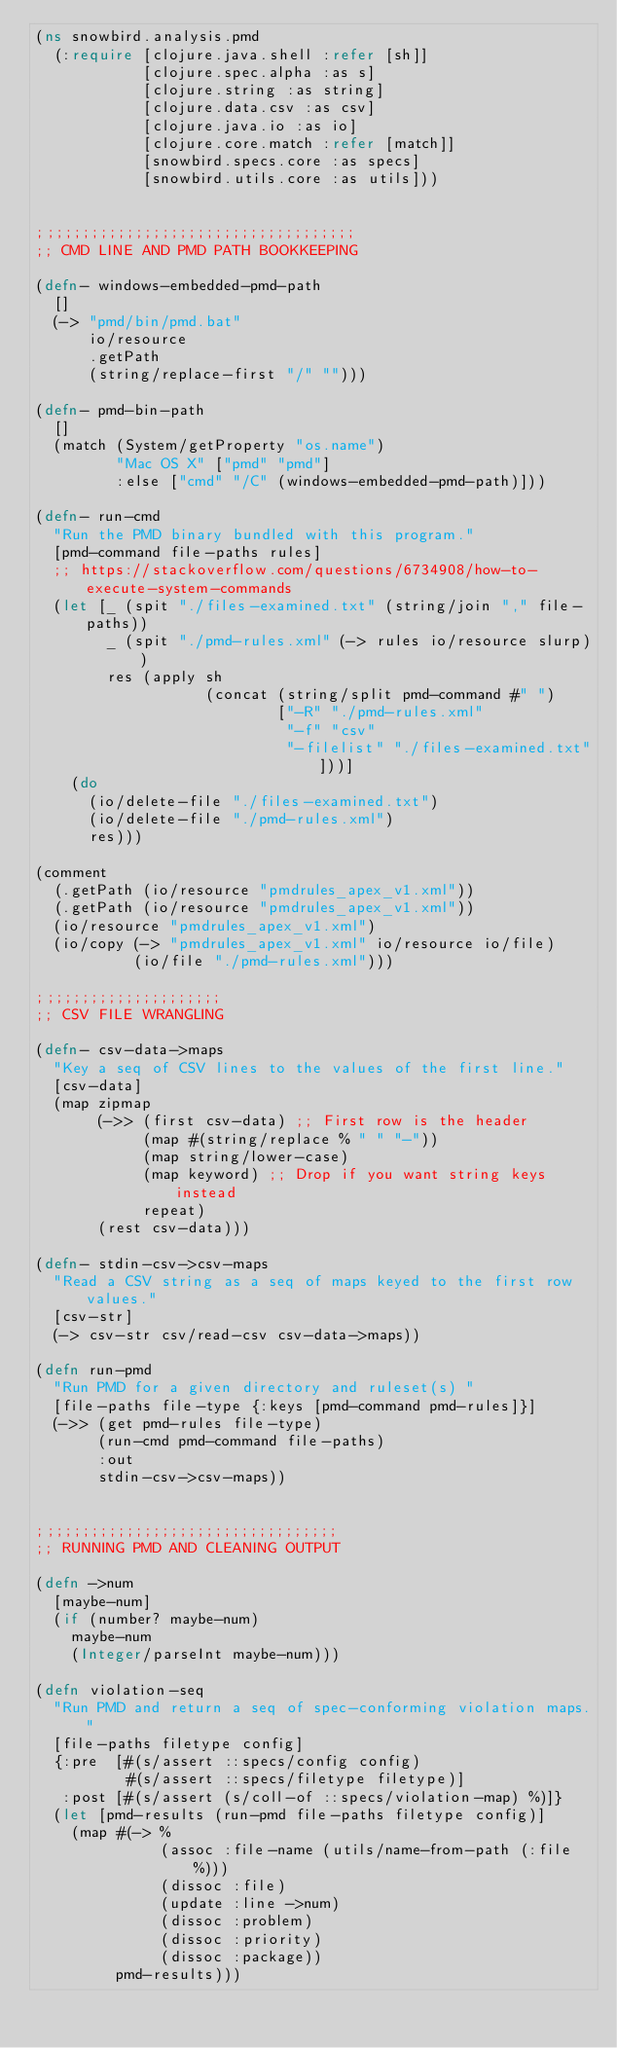<code> <loc_0><loc_0><loc_500><loc_500><_Clojure_>(ns snowbird.analysis.pmd
  (:require [clojure.java.shell :refer [sh]]
            [clojure.spec.alpha :as s]
            [clojure.string :as string]
            [clojure.data.csv :as csv]
            [clojure.java.io :as io]
            [clojure.core.match :refer [match]]
            [snowbird.specs.core :as specs]
            [snowbird.utils.core :as utils]))


;;;;;;;;;;;;;;;;;;;;;;;;;;;;;;;;;;;;
;; CMD LINE AND PMD PATH BOOKKEEPING

(defn- windows-embedded-pmd-path
  []
  (-> "pmd/bin/pmd.bat"
      io/resource
      .getPath
      (string/replace-first "/" "")))

(defn- pmd-bin-path
  []
  (match (System/getProperty "os.name")
         "Mac OS X" ["pmd" "pmd"]
         :else ["cmd" "/C" (windows-embedded-pmd-path)]))

(defn- run-cmd
  "Run the PMD binary bundled with this program."
  [pmd-command file-paths rules]
  ;; https://stackoverflow.com/questions/6734908/how-to-execute-system-commands
  (let [_ (spit "./files-examined.txt" (string/join "," file-paths))
        _ (spit "./pmd-rules.xml" (-> rules io/resource slurp))
        res (apply sh
                   (concat (string/split pmd-command #" ")
                           ["-R" "./pmd-rules.xml"
                            "-f" "csv"
                            "-filelist" "./files-examined.txt"]))]
    (do
      (io/delete-file "./files-examined.txt")
      (io/delete-file "./pmd-rules.xml")
      res)))

(comment
  (.getPath (io/resource "pmdrules_apex_v1.xml"))
  (.getPath (io/resource "pmdrules_apex_v1.xml"))
  (io/resource "pmdrules_apex_v1.xml")
  (io/copy (-> "pmdrules_apex_v1.xml" io/resource io/file)
           (io/file "./pmd-rules.xml")))

;;;;;;;;;;;;;;;;;;;;;
;; CSV FILE WRANGLING

(defn- csv-data->maps
  "Key a seq of CSV lines to the values of the first line."
  [csv-data]
  (map zipmap
       (->> (first csv-data) ;; First row is the header
            (map #(string/replace % " " "-"))
            (map string/lower-case)
            (map keyword) ;; Drop if you want string keys instead
            repeat)
       (rest csv-data)))

(defn- stdin-csv->csv-maps
  "Read a CSV string as a seq of maps keyed to the first row values."
  [csv-str]
  (-> csv-str csv/read-csv csv-data->maps))

(defn run-pmd
  "Run PMD for a given directory and ruleset(s) "
  [file-paths file-type {:keys [pmd-command pmd-rules]}]
  (->> (get pmd-rules file-type)
       (run-cmd pmd-command file-paths)
       :out
       stdin-csv->csv-maps))


;;;;;;;;;;;;;;;;;;;;;;;;;;;;;;;;;;
;; RUNNING PMD AND CLEANING OUTPUT

(defn ->num
  [maybe-num]
  (if (number? maybe-num)
    maybe-num
    (Integer/parseInt maybe-num)))

(defn violation-seq
  "Run PMD and return a seq of spec-conforming violation maps."
  [file-paths filetype config]
  {:pre  [#(s/assert ::specs/config config)
          #(s/assert ::specs/filetype filetype)]
   :post [#(s/assert (s/coll-of ::specs/violation-map) %)]}
  (let [pmd-results (run-pmd file-paths filetype config)]
    (map #(-> %
              (assoc :file-name (utils/name-from-path (:file %)))
              (dissoc :file)
              (update :line ->num)
              (dissoc :problem)
              (dissoc :priority)
              (dissoc :package))
         pmd-results)))

</code> 